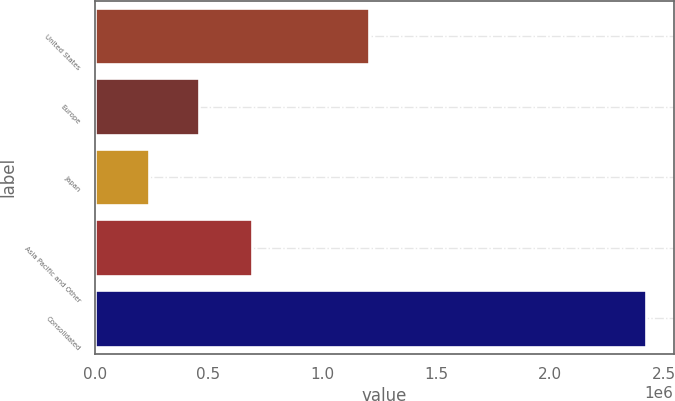Convert chart. <chart><loc_0><loc_0><loc_500><loc_500><bar_chart><fcel>United States<fcel>Europe<fcel>Japan<fcel>Asia Pacific and Other<fcel>Consolidated<nl><fcel>1.20588e+06<fcel>458221<fcel>239964<fcel>689307<fcel>2.42253e+06<nl></chart> 